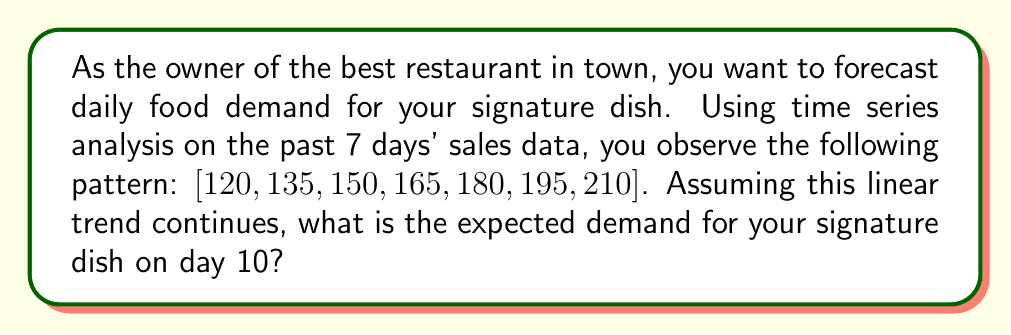Provide a solution to this math problem. To forecast the demand for day 10, we'll use a simple linear regression model based on the given time series data.

Step 1: Identify the pattern
The series shows a clear linear trend with a constant increase of 15 units per day.

Step 2: Find the slope (m) of the linear trend
$m = \frac{\text{change in y}}{\text{change in x}} = \frac{210 - 120}{7 - 1} = \frac{90}{6} = 15$

Step 3: Find the y-intercept (b) using the first data point (day 1, 120)
$y = mx + b$
$120 = 15(1) + b$
$b = 120 - 15 = 105$

Step 4: Write the linear equation
$y = 15x + 105$, where $x$ is the day number and $y$ is the demand

Step 5: Calculate the expected demand for day 10
$y = 15(10) + 105 = 150 + 105 = 255$

Therefore, the expected demand for the signature dish on day 10 is 255 units.
Answer: 255 units 